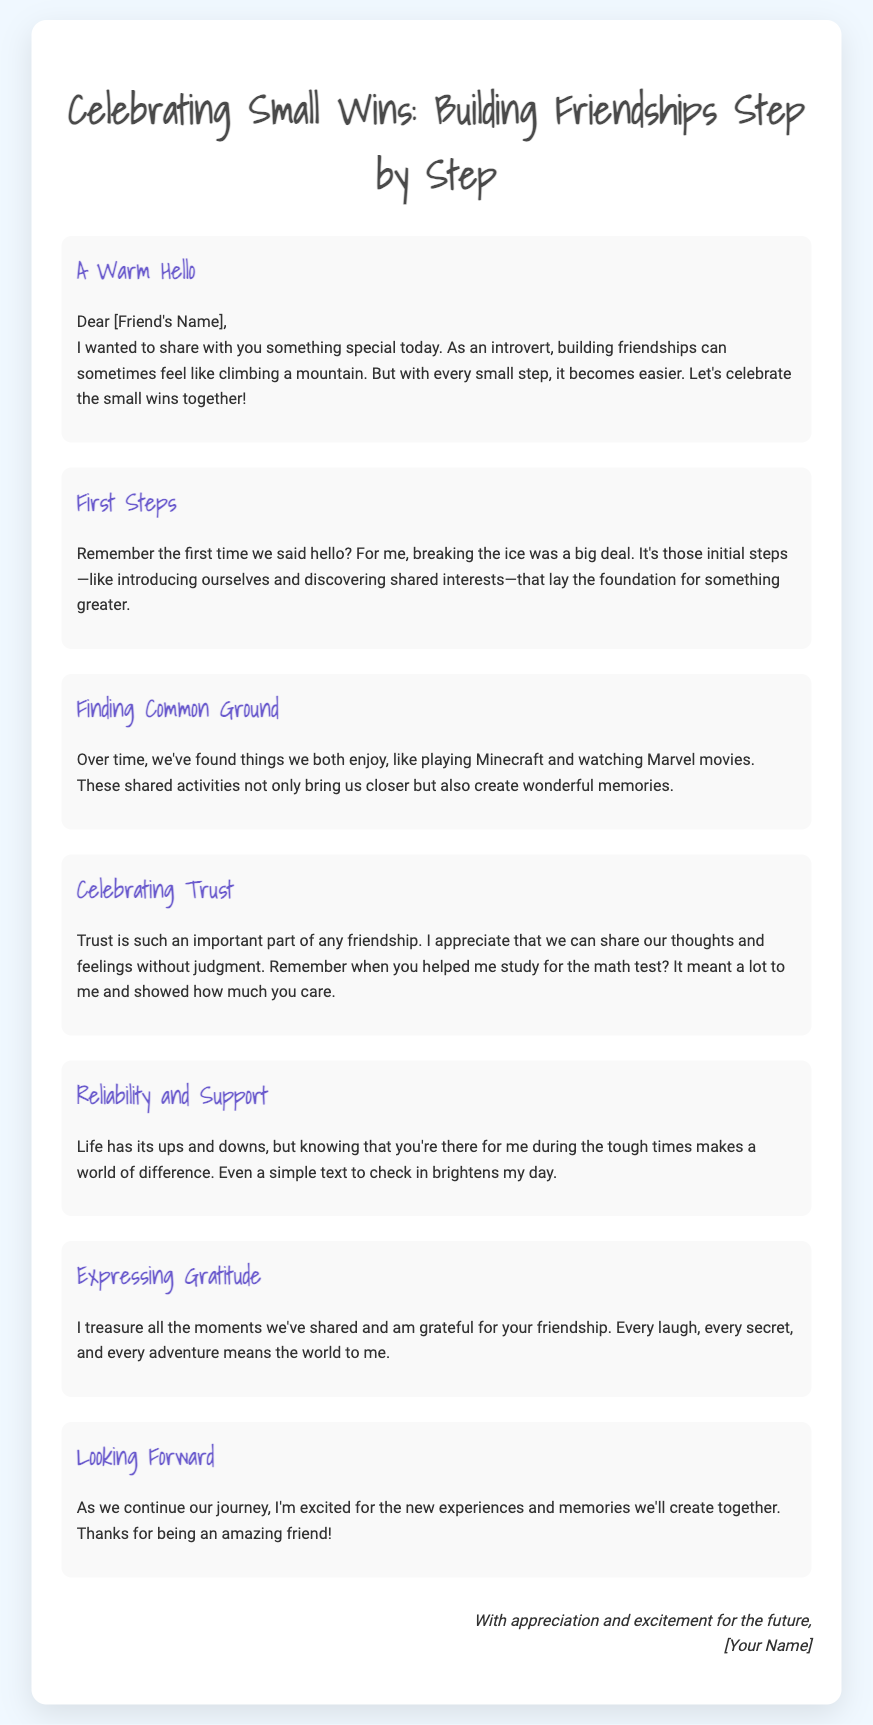what is the title of the card? The title is prominently displayed at the top of the card in a large font.
Answer: Celebrating Small Wins: Building Friendships Step by Step who is the greeting card addressed to? The greeting card includes a placeholder indicating the recipient's name.
Answer: [Friend's Name] what activity is mentioned as something enjoyed by the friends? The card lists activities that helped to strengthen their bond.
Answer: playing Minecraft what does the author appreciate in the friendship? The author expresses gratitude for an important quality in their relationship.
Answer: trust how does the author describe the impact of their friend during tough times? The author highlights a specific type of support that their friend provides.
Answer: reliability what is a celebration referenced in the card? The card mentions celebrating a foundational part of their relationship.
Answer: small wins what does the author express excitement about? The author looks positively toward future experiences shared with friends.
Answer: new experiences and memories what compliments are made about friendship in the card? The author shares their feelings about the moments they treasure together.
Answer: gratitude 